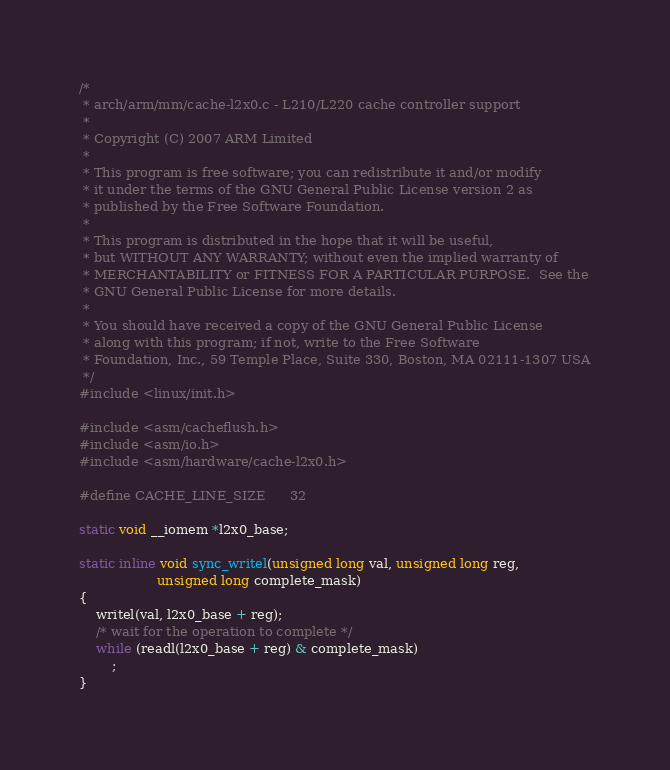<code> <loc_0><loc_0><loc_500><loc_500><_C_>/*
 * arch/arm/mm/cache-l2x0.c - L210/L220 cache controller support
 *
 * Copyright (C) 2007 ARM Limited
 *
 * This program is free software; you can redistribute it and/or modify
 * it under the terms of the GNU General Public License version 2 as
 * published by the Free Software Foundation.
 *
 * This program is distributed in the hope that it will be useful,
 * but WITHOUT ANY WARRANTY; without even the implied warranty of
 * MERCHANTABILITY or FITNESS FOR A PARTICULAR PURPOSE.  See the
 * GNU General Public License for more details.
 *
 * You should have received a copy of the GNU General Public License
 * along with this program; if not, write to the Free Software
 * Foundation, Inc., 59 Temple Place, Suite 330, Boston, MA 02111-1307 USA
 */
#include <linux/init.h>

#include <asm/cacheflush.h>
#include <asm/io.h>
#include <asm/hardware/cache-l2x0.h>

#define CACHE_LINE_SIZE		32

static void __iomem *l2x0_base;

static inline void sync_writel(unsigned long val, unsigned long reg,
			       unsigned long complete_mask)
{
	writel(val, l2x0_base + reg);
	/* wait for the operation to complete */
	while (readl(l2x0_base + reg) & complete_mask)
		;
}
</code> 